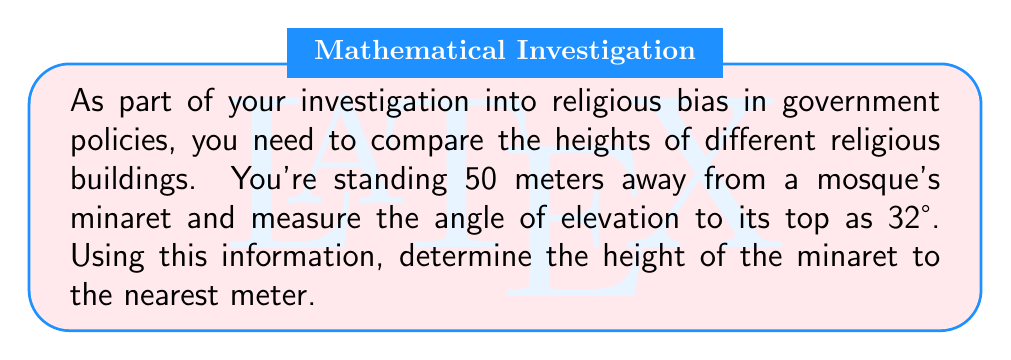Solve this math problem. To solve this problem, we'll use the tangent trigonometric ratio. Here's the step-by-step solution:

1. Visualize the problem:
   [asy]
   import geometry;
   
   size(200);
   
   pair A = (0,0);
   pair B = (50,0);
   pair C = (50,31.8);
   
   draw(A--B--C--A);
   
   label("50 m", (25,0), S);
   label("h", (50,15), E);
   label("32°", (0,0), NW);
   
   draw(rightanglemark(B,A,C,20));
   [/asy]

2. Identify the known values:
   - Adjacent side (distance from observer to minaret) = 50 meters
   - Angle of elevation = 32°

3. Recall the tangent ratio:
   $$ \tan \theta = \frac{\text{opposite}}{\text{adjacent}} $$

4. In this case, we want to find the opposite side (height of the minaret):
   $$ \tan 32° = \frac{h}{50} $$

5. Rearrange the equation to solve for h:
   $$ h = 50 \tan 32° $$

6. Calculate the result:
   $$ h = 50 \times 0.6249 = 31.245 \text{ meters} $$

7. Round to the nearest meter:
   $$ h \approx 31 \text{ meters} $$
Answer: 31 meters 